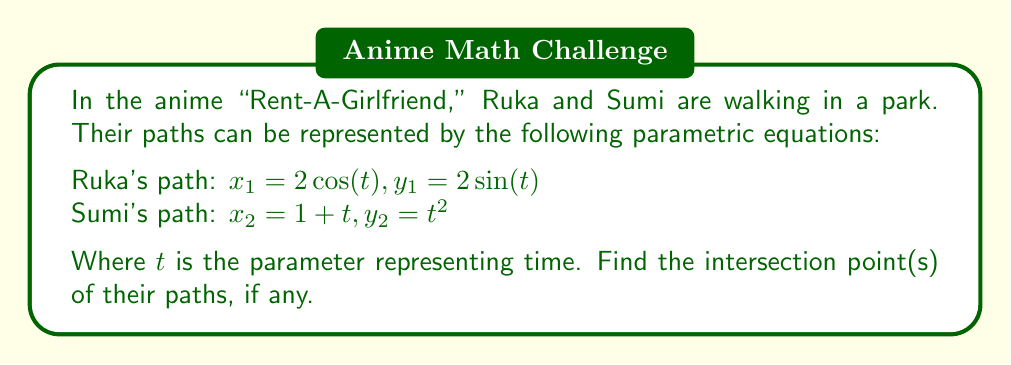Help me with this question. To find the intersection points, we need to solve the system of equations:

$$\begin{cases}
2\cos(t) = 1 + s \\
2\sin(t) = s^2
\end{cases}$$

Where $t$ is the parameter for Ruka's path and $s$ is the parameter for Sumi's path.

1) From the first equation:
   $\cos(t) = \frac{1+s}{2}$

2) Square both sides of this equation:
   $\cos^2(t) = (\frac{1+s}{2})^2$

3) Use the identity $\sin^2(t) + \cos^2(t) = 1$:
   $1 - \sin^2(t) = (\frac{1+s}{2})^2$

4) Substitute $\sin(t) = \frac{s^2}{2}$ from the second original equation:
   $1 - (\frac{s^2}{2})^2 = (\frac{1+s}{2})^2$

5) Expand:
   $1 - \frac{s^4}{4} = \frac{1+2s+s^2}{4}$

6) Multiply both sides by 4:
   $4 - s^4 = 1+2s+s^2$

7) Rearrange:
   $s^4 + s^2 + 2s - 3 = 0$

8) This is a 4th degree polynomial equation. It can be solved using numerical methods or a graphing calculator.

9) The solutions are approximately $s \approx 1.2470$ and $s \approx -1.6506$

10) We can discard the negative solution as $s$ represents time.

11) For $s \approx 1.2470$:
    $x = 1 + 1.2470 \approx 2.2470$
    $y = (1.2470)^2 \approx 1.5550$

12) We can verify this point satisfies Ruka's equations:
    $\cos(t) \approx 0.6235$ and $\sin(t) \approx 0.7775$
    Which gives $t \approx 0.8960$

Therefore, the paths intersect at approximately (2.2470, 1.5550).
Answer: The paths of Ruka and Sumi intersect at approximately (2.2470, 1.5550). 